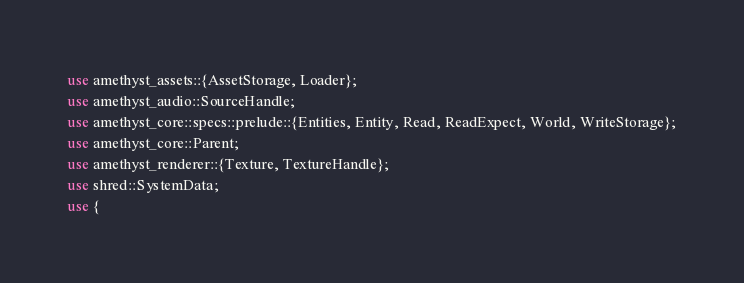<code> <loc_0><loc_0><loc_500><loc_500><_Rust_>use amethyst_assets::{AssetStorage, Loader};
use amethyst_audio::SourceHandle;
use amethyst_core::specs::prelude::{Entities, Entity, Read, ReadExpect, World, WriteStorage};
use amethyst_core::Parent;
use amethyst_renderer::{Texture, TextureHandle};
use shred::SystemData;
use {</code> 